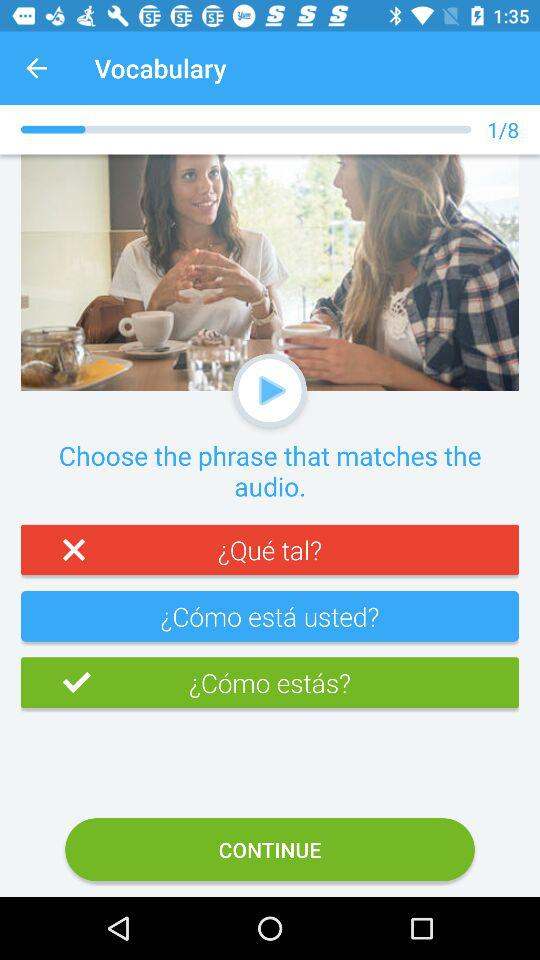On which question number am I? You are on question number 1. 